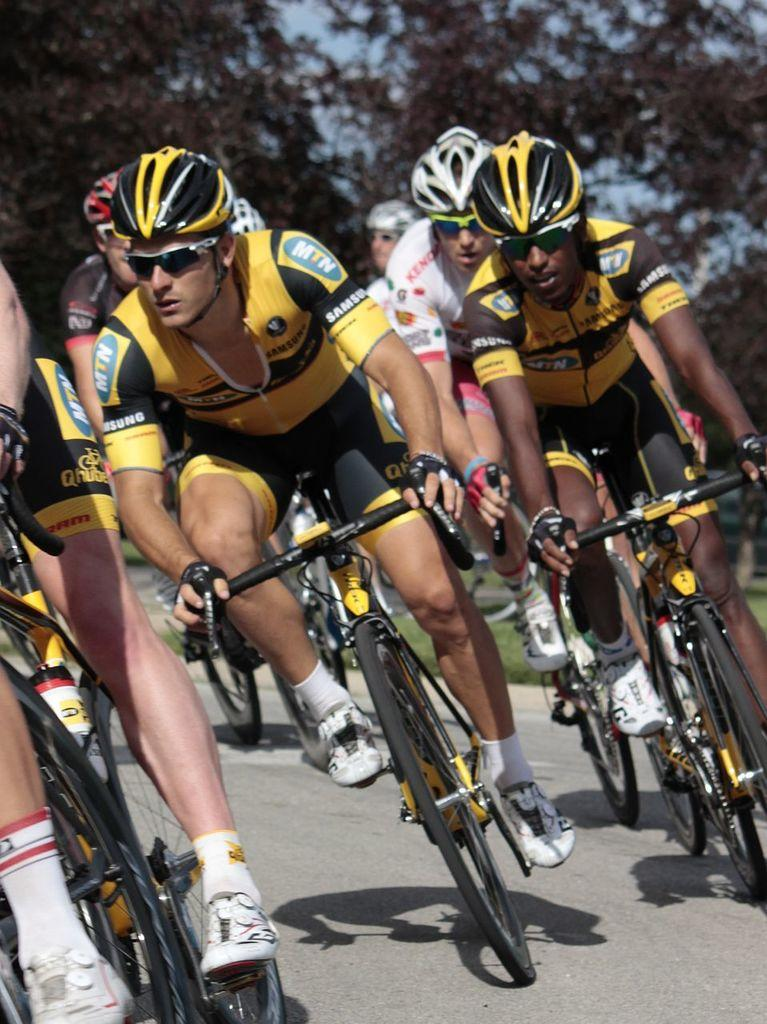What activity are the persons in the image engaged in? The persons in the image are cycling. Where is the cycling taking place? The cycling is taking place on the floor. What can be seen in the background of the image? There are trees and the sky visible in the background of the image. What type of bottle can be seen in the image? There is no bottle present in the image. How does the acoustics of the cycling sound in the image? The image does not provide any information about the acoustics of the cycling. 